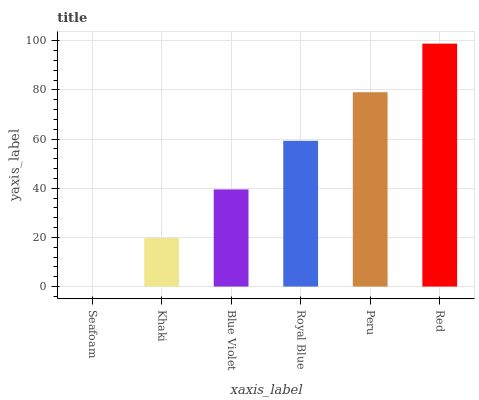Is Khaki the minimum?
Answer yes or no. No. Is Khaki the maximum?
Answer yes or no. No. Is Khaki greater than Seafoam?
Answer yes or no. Yes. Is Seafoam less than Khaki?
Answer yes or no. Yes. Is Seafoam greater than Khaki?
Answer yes or no. No. Is Khaki less than Seafoam?
Answer yes or no. No. Is Royal Blue the high median?
Answer yes or no. Yes. Is Blue Violet the low median?
Answer yes or no. Yes. Is Khaki the high median?
Answer yes or no. No. Is Red the low median?
Answer yes or no. No. 